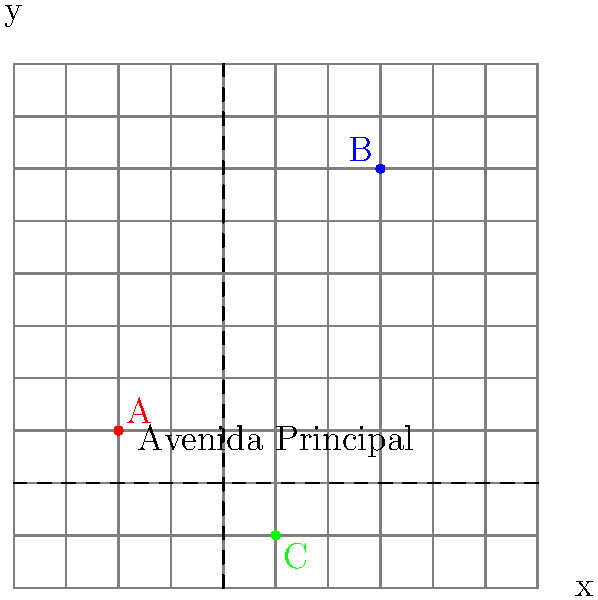You've just arrived in a new city in the United States and are trying to navigate using a map with a coordinate grid. The map shows three important landmarks: A (red), B (blue), and C (green). Avenida Principal runs horizontally at y = 2, and Rua Central runs vertically at x = 4. What are the coordinates of landmark B, and how many blocks east of Rua Central is it located? To solve this problem, let's follow these steps:

1. Identify the coordinate system:
   The map uses a standard coordinate grid where x increases from left to right, and y increases from bottom to top.

2. Locate landmark B:
   The blue dot representing landmark B is positioned in the upper right quadrant of the map.

3. Determine the coordinates of B:
   By counting the grid lines, we can see that B is located at the point (7, 8).

4. Identify the position of Rua Central:
   Rua Central is the vertical street located at x = 4.

5. Calculate the distance between B and Rua Central:
   The x-coordinate of B is 7, and Rua Central is at x = 4.
   The distance east of Rua Central is: 7 - 4 = 3 blocks

Therefore, landmark B is located at coordinates (7, 8) and is 3 blocks east of Rua Central.
Answer: (7, 8), 3 blocks 